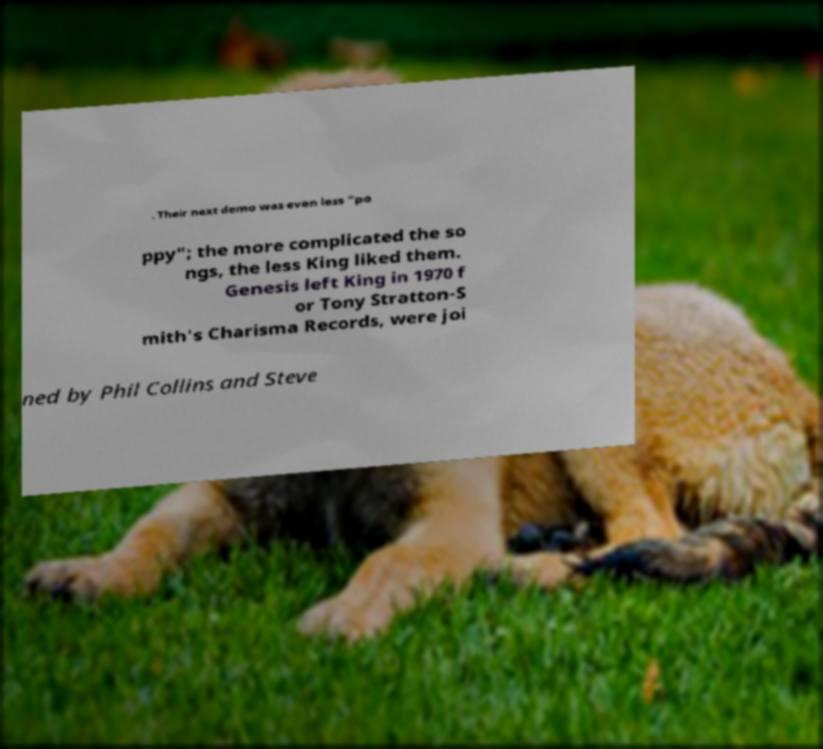Could you extract and type out the text from this image? . Their next demo was even less "po ppy"; the more complicated the so ngs, the less King liked them. Genesis left King in 1970 f or Tony Stratton-S mith's Charisma Records, were joi ned by Phil Collins and Steve 